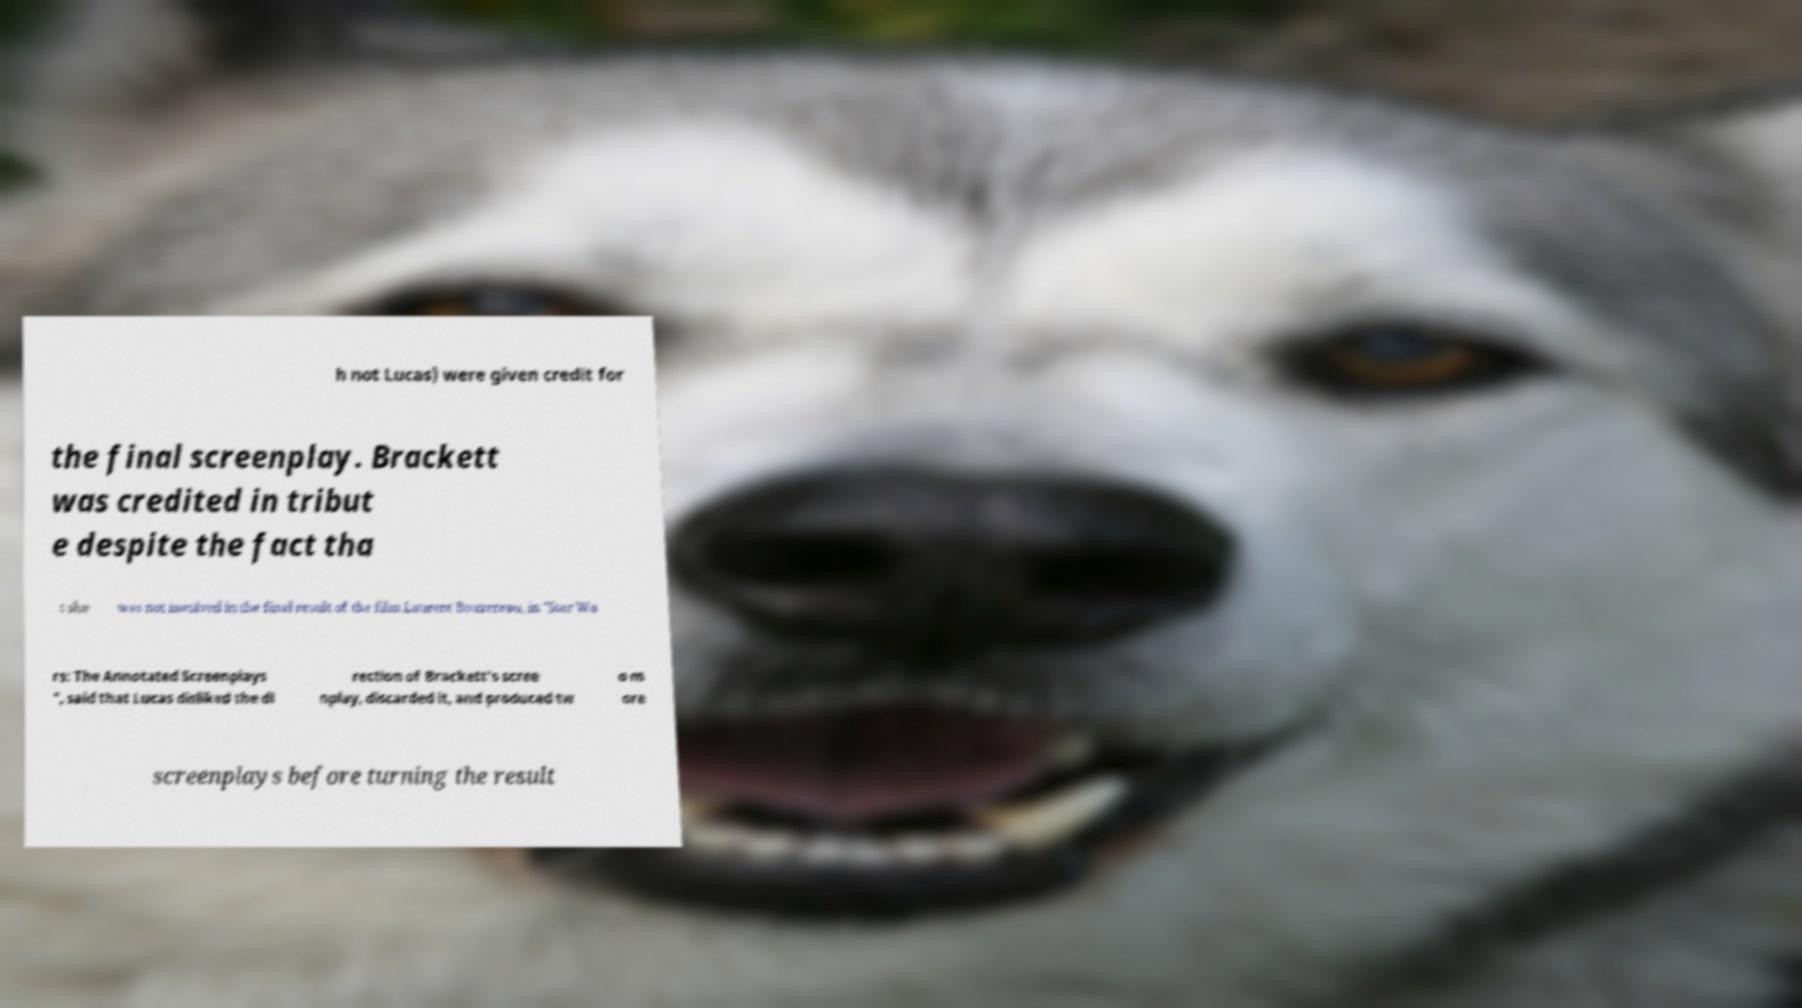Could you assist in decoding the text presented in this image and type it out clearly? h not Lucas) were given credit for the final screenplay. Brackett was credited in tribut e despite the fact tha t she was not involved in the final result of the film.Laurent Bouzereau, in "Star Wa rs: The Annotated Screenplays ", said that Lucas disliked the di rection of Brackett's scree nplay, discarded it, and produced tw o m ore screenplays before turning the result 